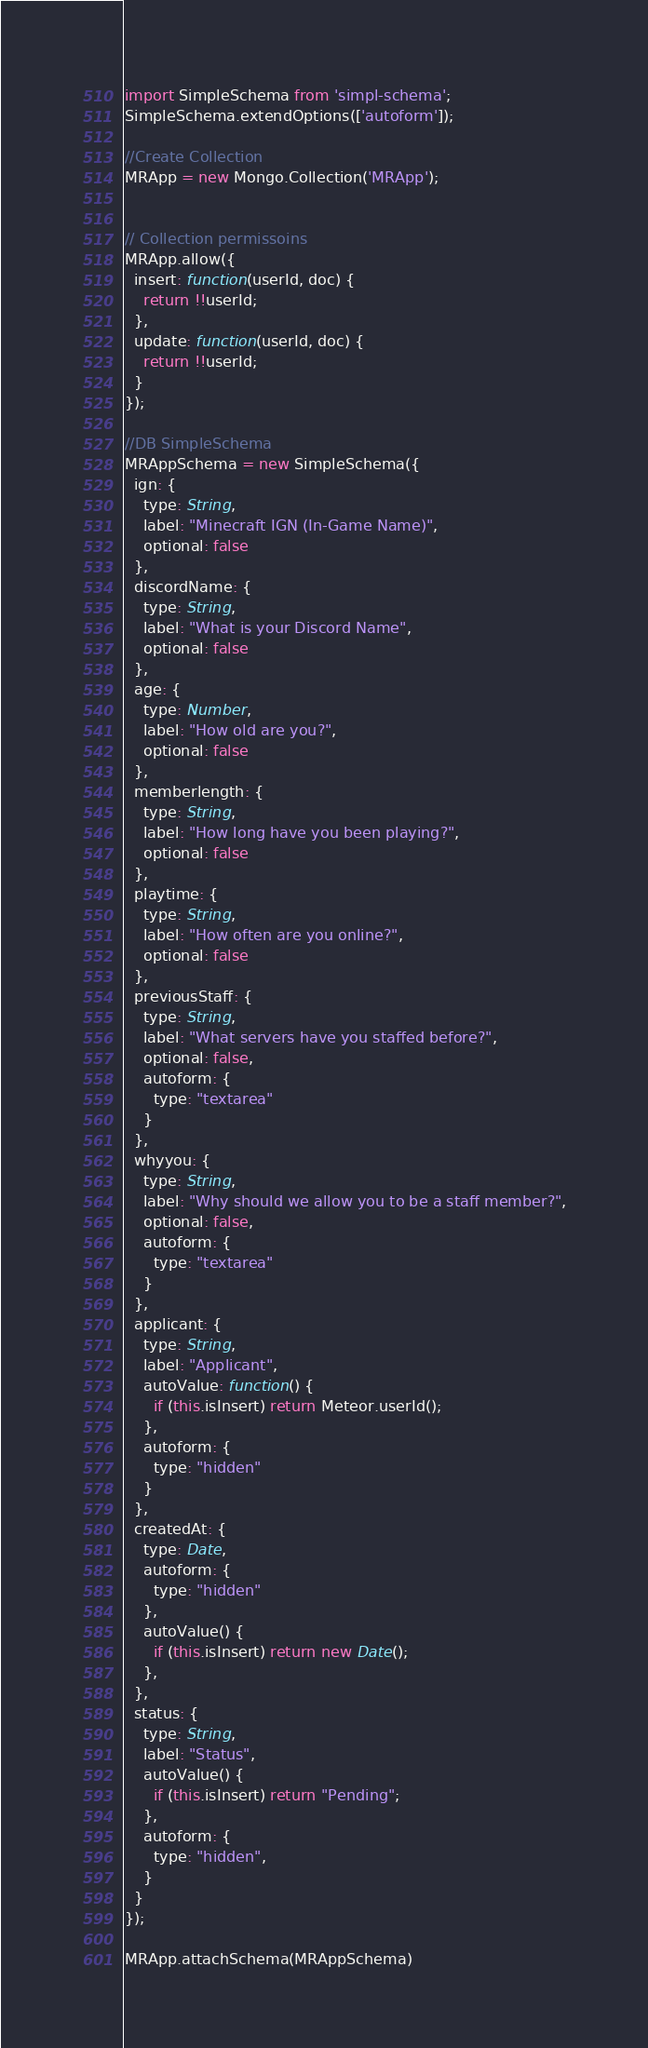Convert code to text. <code><loc_0><loc_0><loc_500><loc_500><_JavaScript_>import SimpleSchema from 'simpl-schema';
SimpleSchema.extendOptions(['autoform']);

//Create Collection
MRApp = new Mongo.Collection('MRApp');


// Collection permissoins
MRApp.allow({
  insert: function(userId, doc) {
    return !!userId;
  },
  update: function(userId, doc) {
    return !!userId;
  }
});

//DB SimpleSchema
MRAppSchema = new SimpleSchema({
  ign: {
    type: String,
    label: "Minecraft IGN (In-Game Name)",
    optional: false
  },
  discordName: {
    type: String,
    label: "What is your Discord Name",
    optional: false
  },
  age: {
    type: Number,
    label: "How old are you?",
    optional: false
  },
  memberlength: {
    type: String,
    label: "How long have you been playing?",
    optional: false
  },
  playtime: {
    type: String,
    label: "How often are you online?",
    optional: false
  },
  previousStaff: {
    type: String,
    label: "What servers have you staffed before?",
    optional: false,
    autoform: {
      type: "textarea"
    }
  },
  whyyou: {
    type: String,
    label: "Why should we allow you to be a staff member?",
    optional: false,
    autoform: {
      type: "textarea"
    }
  },
  applicant: {
    type: String,
    label: "Applicant",
    autoValue: function() {
      if (this.isInsert) return Meteor.userId();
    },
    autoform: {
      type: "hidden"
    }
  },
  createdAt: {
    type: Date,
    autoform: {
      type: "hidden"
    },
    autoValue() {
      if (this.isInsert) return new Date();
    },
  },
  status: {
    type: String,
    label: "Status",
    autoValue() {
      if (this.isInsert) return "Pending";
    },
    autoform: {
      type: "hidden",
    }
  }
});

MRApp.attachSchema(MRAppSchema)
</code> 